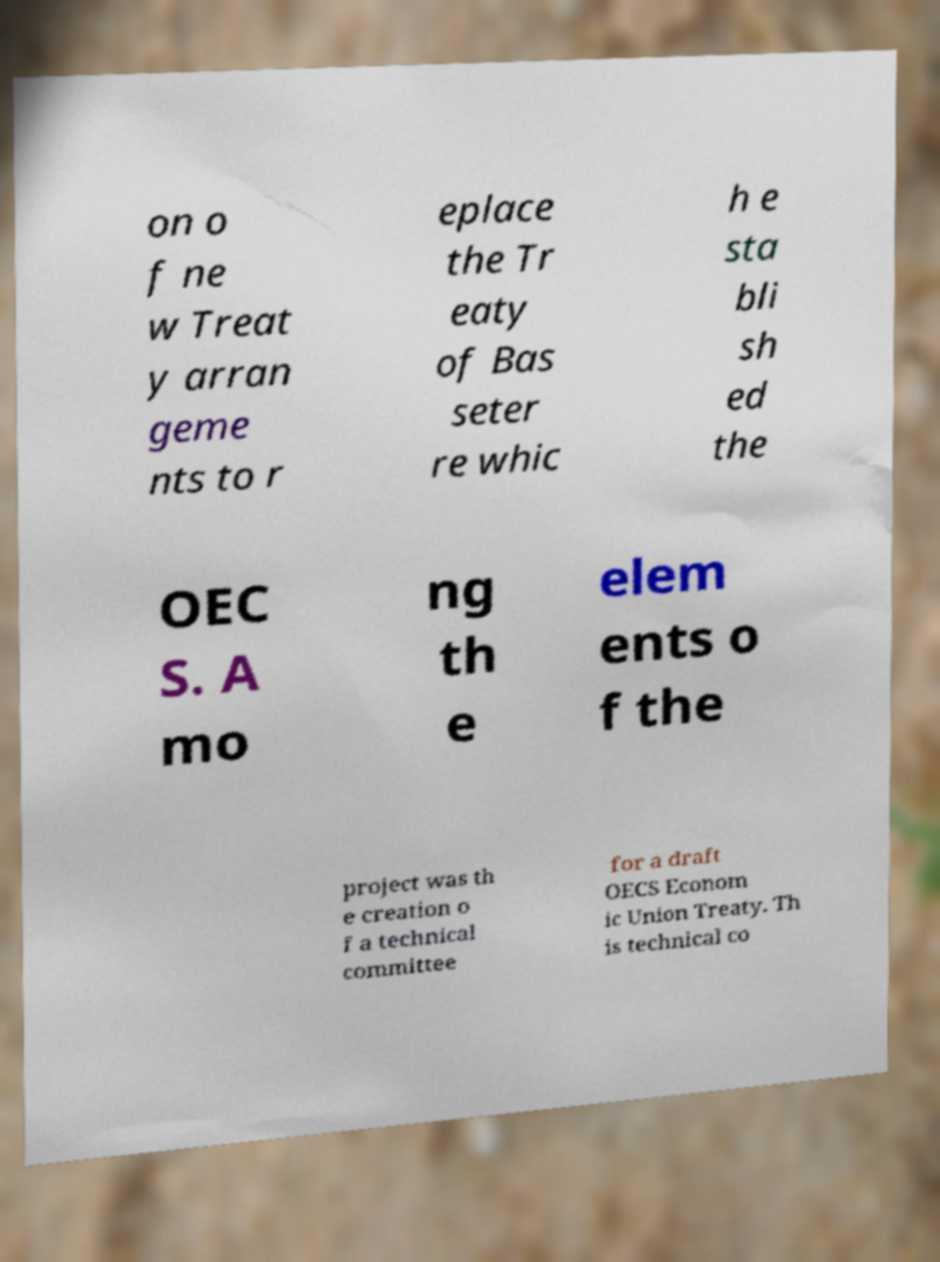Could you assist in decoding the text presented in this image and type it out clearly? on o f ne w Treat y arran geme nts to r eplace the Tr eaty of Bas seter re whic h e sta bli sh ed the OEC S. A mo ng th e elem ents o f the project was th e creation o f a technical committee for a draft OECS Econom ic Union Treaty. Th is technical co 